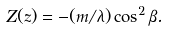<formula> <loc_0><loc_0><loc_500><loc_500>Z ( z ) = - ( m / \lambda ) \cos ^ { 2 } \beta .</formula> 